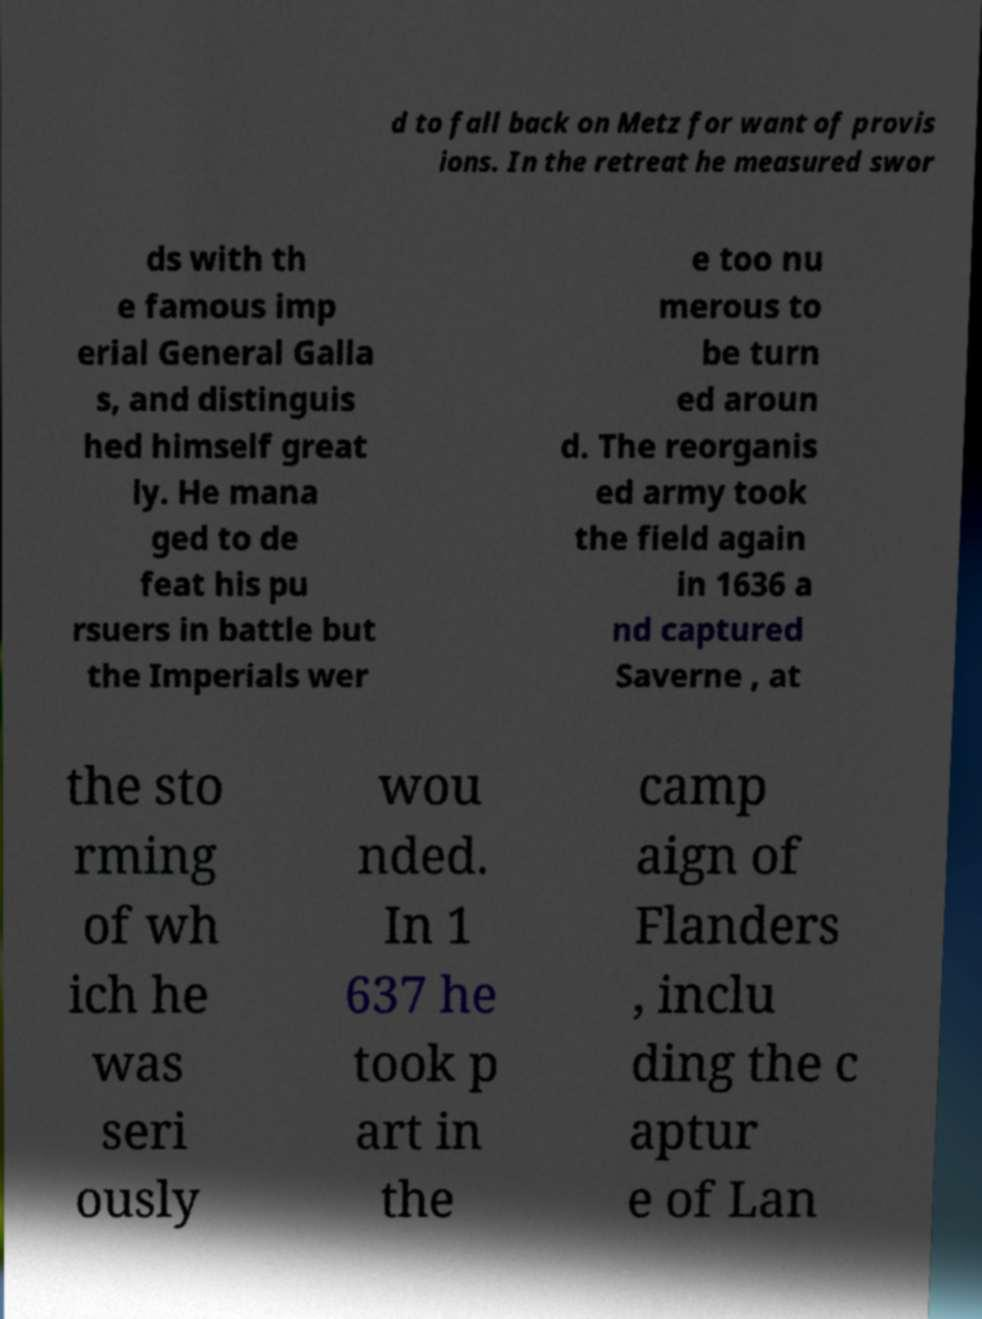For documentation purposes, I need the text within this image transcribed. Could you provide that? d to fall back on Metz for want of provis ions. In the retreat he measured swor ds with th e famous imp erial General Galla s, and distinguis hed himself great ly. He mana ged to de feat his pu rsuers in battle but the Imperials wer e too nu merous to be turn ed aroun d. The reorganis ed army took the field again in 1636 a nd captured Saverne , at the sto rming of wh ich he was seri ously wou nded. In 1 637 he took p art in the camp aign of Flanders , inclu ding the c aptur e of Lan 